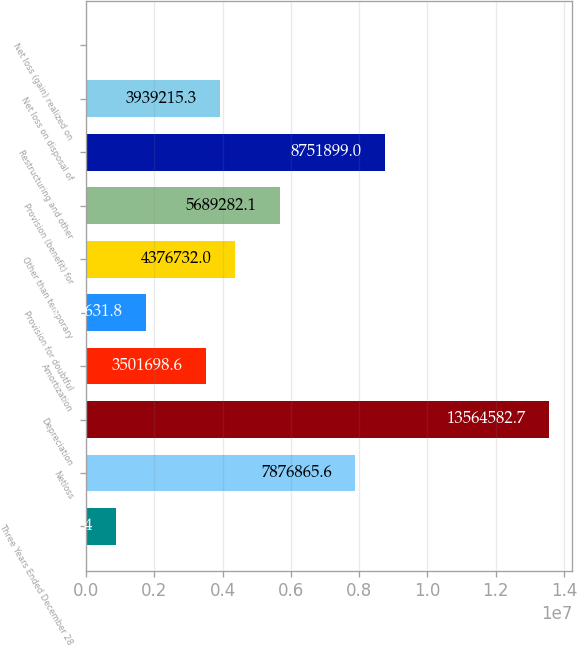Convert chart to OTSL. <chart><loc_0><loc_0><loc_500><loc_500><bar_chart><fcel>Three Years Ended December 28<fcel>Netloss<fcel>Depreciation<fcel>Amortization<fcel>Provision for doubtful<fcel>Other than temporary<fcel>Provision (benefit) for<fcel>Restructuring and other<fcel>Net loss on disposal of<fcel>Net loss (gain) realized on<nl><fcel>876598<fcel>7.87687e+06<fcel>1.35646e+07<fcel>3.5017e+06<fcel>1.75163e+06<fcel>4.37673e+06<fcel>5.68928e+06<fcel>8.7519e+06<fcel>3.93922e+06<fcel>1565<nl></chart> 